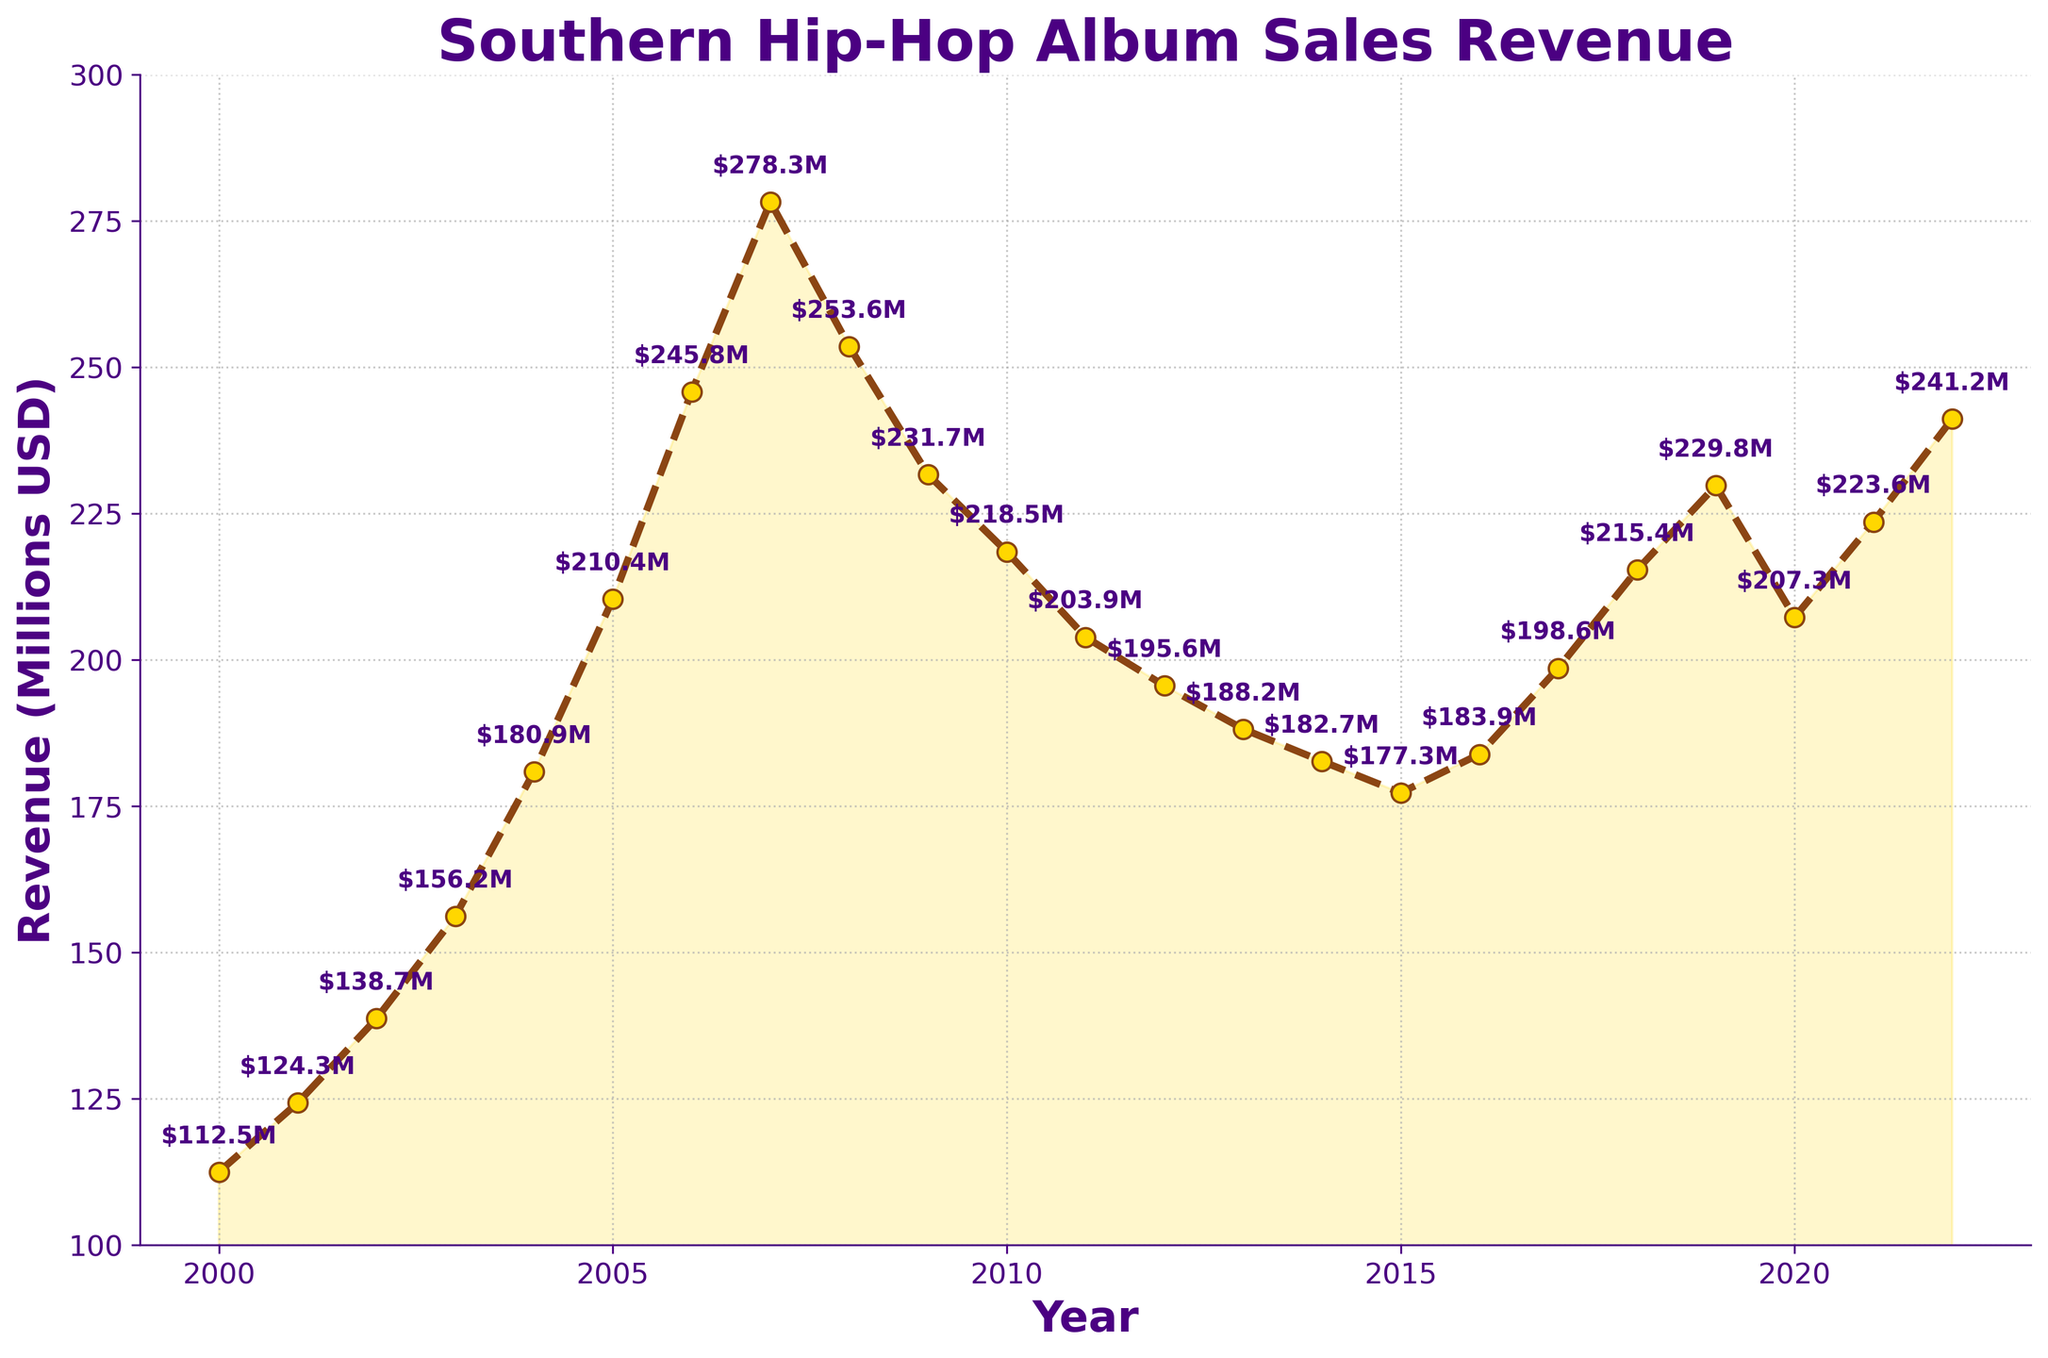What is the general trend of the yearly revenue from hip-hop album sales in the Southern United States from 2000 to 2022? The general trend can be observed by noting the shape of the line plot from the start year to the end year. The revenue appears to increase from 2000 to a peak around 2007, then declines until about 2014, followed by a recovery trend until the end of the timeframe.
Answer: Increase, then decline, then recovery Which year saw the highest revenue from hip-hop album sales according to the chart? To determine the highest revenue year, identify the peak in the line plot. The highest point is in 2007.
Answer: 2007 What is the total revenue made from hip-hop album sales in the Southern United States over the period 2000 to 2022? Sum up the revenues from each year listed in the plot: 112.5 + 124.3 + 138.7 + 156.2 + 180.9 + 210.4 + 245.8 + 278.3 + 253.6 + 231.7 + 218.5 + 203.9 + 195.6 + 188.2 + 182.7 + 177.3 + 183.9 + 198.6 + 215.4 + 229.8 + 207.3 + 223.6 + 241.2.
Answer: 4468.5 million USD During which period did the revenue see the sharpest decline? Look for the part of the plot where the slope is steepest downward. The sharpest decline is from 2007 to 2011.
Answer: 2007-2011 How much did the revenue drop from its peak in 2007 to its lowest point in the plot? Identify the peak value (278.3 million USD in 2007) and the lowest value (177.3 million USD in 2015), then subtract the lowest from the peak: 278.3 - 177.3.
Answer: 101 million USD Which year had a higher revenue: 2012 or 2015? Compare the values directly: 195.6 million USD in 2012 and 177.3 million USD in 2015.
Answer: 2012 What is the average yearly revenue between 2000 and 2022? Calculate the average revenue by summing all yearly revenues and then dividing by the number of years: (total revenue over 2000 to 2022) / 23.
Answer: 194.28 million USD Was there any year where the revenue dropped two years in a row? Look for consecutive declines in the plot. The years 2008 to 2010 and 2010 to 2013 show consecutive declines.
Answer: Yes, multiple instances Between which years did the revenue increase the most? Identify the years with the largest positive difference in values: from 2005 (210.4) to 2006 (245.8).
Answer: 2005-2006 What visual elements in the plot help highlight the trend over the years? Identify elements such as lines, colors, markers, and fill areas. The plot uses a brown dashed line with gold markers, an area fill between the line and the x-axis, and annotations for revenue values.
Answer: Brown dashed line, gold markers, area fill, annotations 